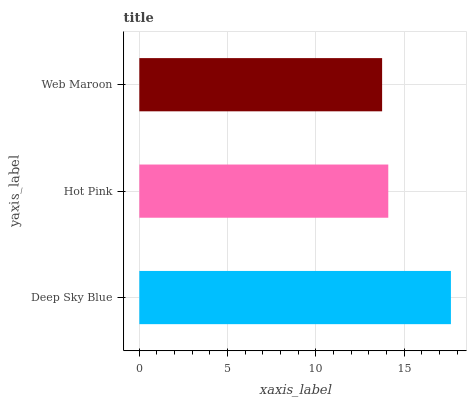Is Web Maroon the minimum?
Answer yes or no. Yes. Is Deep Sky Blue the maximum?
Answer yes or no. Yes. Is Hot Pink the minimum?
Answer yes or no. No. Is Hot Pink the maximum?
Answer yes or no. No. Is Deep Sky Blue greater than Hot Pink?
Answer yes or no. Yes. Is Hot Pink less than Deep Sky Blue?
Answer yes or no. Yes. Is Hot Pink greater than Deep Sky Blue?
Answer yes or no. No. Is Deep Sky Blue less than Hot Pink?
Answer yes or no. No. Is Hot Pink the high median?
Answer yes or no. Yes. Is Hot Pink the low median?
Answer yes or no. Yes. Is Deep Sky Blue the high median?
Answer yes or no. No. Is Web Maroon the low median?
Answer yes or no. No. 